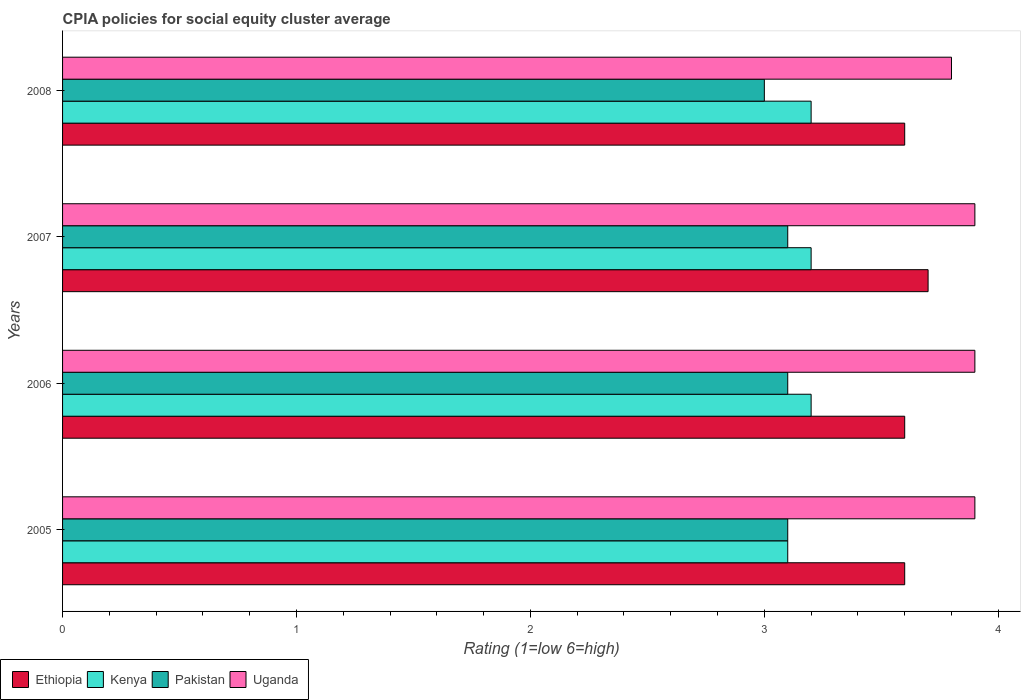Are the number of bars per tick equal to the number of legend labels?
Make the answer very short. Yes. Are the number of bars on each tick of the Y-axis equal?
Your response must be concise. Yes. In how many cases, is the number of bars for a given year not equal to the number of legend labels?
Keep it short and to the point. 0. Across all years, what is the maximum CPIA rating in Pakistan?
Give a very brief answer. 3.1. In which year was the CPIA rating in Pakistan minimum?
Offer a terse response. 2008. What is the difference between the CPIA rating in Kenya in 2006 and that in 2007?
Offer a terse response. 0. What is the difference between the CPIA rating in Uganda in 2006 and the CPIA rating in Ethiopia in 2007?
Keep it short and to the point. 0.2. What is the average CPIA rating in Ethiopia per year?
Keep it short and to the point. 3.62. In the year 2006, what is the difference between the CPIA rating in Ethiopia and CPIA rating in Uganda?
Give a very brief answer. -0.3. What is the ratio of the CPIA rating in Pakistan in 2005 to that in 2008?
Keep it short and to the point. 1.03. Is the difference between the CPIA rating in Ethiopia in 2007 and 2008 greater than the difference between the CPIA rating in Uganda in 2007 and 2008?
Keep it short and to the point. No. What is the difference between the highest and the lowest CPIA rating in Ethiopia?
Keep it short and to the point. 0.1. Is it the case that in every year, the sum of the CPIA rating in Kenya and CPIA rating in Uganda is greater than the sum of CPIA rating in Pakistan and CPIA rating in Ethiopia?
Provide a succinct answer. No. What does the 3rd bar from the top in 2006 represents?
Make the answer very short. Kenya. What does the 3rd bar from the bottom in 2007 represents?
Ensure brevity in your answer.  Pakistan. Is it the case that in every year, the sum of the CPIA rating in Pakistan and CPIA rating in Uganda is greater than the CPIA rating in Kenya?
Offer a terse response. Yes. How many bars are there?
Your answer should be compact. 16. Does the graph contain any zero values?
Keep it short and to the point. No. What is the title of the graph?
Your answer should be compact. CPIA policies for social equity cluster average. Does "Korea (Democratic)" appear as one of the legend labels in the graph?
Your answer should be very brief. No. What is the label or title of the X-axis?
Ensure brevity in your answer.  Rating (1=low 6=high). What is the label or title of the Y-axis?
Give a very brief answer. Years. What is the Rating (1=low 6=high) of Ethiopia in 2005?
Give a very brief answer. 3.6. What is the Rating (1=low 6=high) of Uganda in 2005?
Keep it short and to the point. 3.9. What is the Rating (1=low 6=high) in Ethiopia in 2006?
Provide a short and direct response. 3.6. What is the Rating (1=low 6=high) of Pakistan in 2006?
Your response must be concise. 3.1. What is the Rating (1=low 6=high) in Uganda in 2006?
Offer a very short reply. 3.9. What is the Rating (1=low 6=high) of Ethiopia in 2007?
Your answer should be compact. 3.7. What is the Rating (1=low 6=high) of Uganda in 2008?
Give a very brief answer. 3.8. Across all years, what is the maximum Rating (1=low 6=high) of Kenya?
Make the answer very short. 3.2. Across all years, what is the maximum Rating (1=low 6=high) in Uganda?
Keep it short and to the point. 3.9. Across all years, what is the minimum Rating (1=low 6=high) of Ethiopia?
Provide a short and direct response. 3.6. Across all years, what is the minimum Rating (1=low 6=high) of Kenya?
Keep it short and to the point. 3.1. Across all years, what is the minimum Rating (1=low 6=high) in Pakistan?
Keep it short and to the point. 3. What is the total Rating (1=low 6=high) of Ethiopia in the graph?
Offer a terse response. 14.5. What is the total Rating (1=low 6=high) of Pakistan in the graph?
Offer a very short reply. 12.3. What is the difference between the Rating (1=low 6=high) in Pakistan in 2005 and that in 2006?
Your response must be concise. 0. What is the difference between the Rating (1=low 6=high) in Ethiopia in 2005 and that in 2007?
Offer a very short reply. -0.1. What is the difference between the Rating (1=low 6=high) in Kenya in 2005 and that in 2007?
Provide a short and direct response. -0.1. What is the difference between the Rating (1=low 6=high) of Pakistan in 2005 and that in 2008?
Offer a very short reply. 0.1. What is the difference between the Rating (1=low 6=high) in Ethiopia in 2006 and that in 2007?
Make the answer very short. -0.1. What is the difference between the Rating (1=low 6=high) in Pakistan in 2006 and that in 2007?
Give a very brief answer. 0. What is the difference between the Rating (1=low 6=high) of Uganda in 2006 and that in 2007?
Ensure brevity in your answer.  0. What is the difference between the Rating (1=low 6=high) of Ethiopia in 2006 and that in 2008?
Make the answer very short. 0. What is the difference between the Rating (1=low 6=high) in Pakistan in 2006 and that in 2008?
Keep it short and to the point. 0.1. What is the difference between the Rating (1=low 6=high) in Ethiopia in 2007 and that in 2008?
Your answer should be very brief. 0.1. What is the difference between the Rating (1=low 6=high) in Kenya in 2007 and that in 2008?
Make the answer very short. 0. What is the difference between the Rating (1=low 6=high) in Uganda in 2007 and that in 2008?
Your response must be concise. 0.1. What is the difference between the Rating (1=low 6=high) in Ethiopia in 2005 and the Rating (1=low 6=high) in Pakistan in 2006?
Your answer should be compact. 0.5. What is the difference between the Rating (1=low 6=high) of Kenya in 2005 and the Rating (1=low 6=high) of Uganda in 2006?
Offer a terse response. -0.8. What is the difference between the Rating (1=low 6=high) in Pakistan in 2005 and the Rating (1=low 6=high) in Uganda in 2006?
Provide a succinct answer. -0.8. What is the difference between the Rating (1=low 6=high) in Ethiopia in 2005 and the Rating (1=low 6=high) in Pakistan in 2007?
Offer a terse response. 0.5. What is the difference between the Rating (1=low 6=high) in Ethiopia in 2005 and the Rating (1=low 6=high) in Uganda in 2007?
Offer a very short reply. -0.3. What is the difference between the Rating (1=low 6=high) in Pakistan in 2005 and the Rating (1=low 6=high) in Uganda in 2007?
Offer a terse response. -0.8. What is the difference between the Rating (1=low 6=high) in Ethiopia in 2005 and the Rating (1=low 6=high) in Pakistan in 2008?
Your response must be concise. 0.6. What is the difference between the Rating (1=low 6=high) in Ethiopia in 2005 and the Rating (1=low 6=high) in Uganda in 2008?
Provide a succinct answer. -0.2. What is the difference between the Rating (1=low 6=high) of Ethiopia in 2006 and the Rating (1=low 6=high) of Kenya in 2007?
Your answer should be compact. 0.4. What is the difference between the Rating (1=low 6=high) in Ethiopia in 2006 and the Rating (1=low 6=high) in Uganda in 2007?
Your answer should be compact. -0.3. What is the difference between the Rating (1=low 6=high) in Kenya in 2006 and the Rating (1=low 6=high) in Pakistan in 2007?
Keep it short and to the point. 0.1. What is the difference between the Rating (1=low 6=high) of Ethiopia in 2006 and the Rating (1=low 6=high) of Kenya in 2008?
Your answer should be very brief. 0.4. What is the difference between the Rating (1=low 6=high) of Ethiopia in 2006 and the Rating (1=low 6=high) of Pakistan in 2008?
Make the answer very short. 0.6. What is the difference between the Rating (1=low 6=high) of Ethiopia in 2006 and the Rating (1=low 6=high) of Uganda in 2008?
Give a very brief answer. -0.2. What is the difference between the Rating (1=low 6=high) in Pakistan in 2006 and the Rating (1=low 6=high) in Uganda in 2008?
Ensure brevity in your answer.  -0.7. What is the difference between the Rating (1=low 6=high) of Ethiopia in 2007 and the Rating (1=low 6=high) of Uganda in 2008?
Your answer should be compact. -0.1. What is the difference between the Rating (1=low 6=high) of Pakistan in 2007 and the Rating (1=low 6=high) of Uganda in 2008?
Provide a succinct answer. -0.7. What is the average Rating (1=low 6=high) of Ethiopia per year?
Offer a very short reply. 3.62. What is the average Rating (1=low 6=high) of Kenya per year?
Your response must be concise. 3.17. What is the average Rating (1=low 6=high) of Pakistan per year?
Make the answer very short. 3.08. What is the average Rating (1=low 6=high) in Uganda per year?
Keep it short and to the point. 3.88. In the year 2005, what is the difference between the Rating (1=low 6=high) in Kenya and Rating (1=low 6=high) in Pakistan?
Provide a short and direct response. 0. In the year 2005, what is the difference between the Rating (1=low 6=high) in Kenya and Rating (1=low 6=high) in Uganda?
Your response must be concise. -0.8. In the year 2005, what is the difference between the Rating (1=low 6=high) of Pakistan and Rating (1=low 6=high) of Uganda?
Ensure brevity in your answer.  -0.8. In the year 2006, what is the difference between the Rating (1=low 6=high) in Ethiopia and Rating (1=low 6=high) in Kenya?
Provide a short and direct response. 0.4. In the year 2006, what is the difference between the Rating (1=low 6=high) of Kenya and Rating (1=low 6=high) of Pakistan?
Your answer should be compact. 0.1. In the year 2006, what is the difference between the Rating (1=low 6=high) in Kenya and Rating (1=low 6=high) in Uganda?
Make the answer very short. -0.7. In the year 2007, what is the difference between the Rating (1=low 6=high) in Ethiopia and Rating (1=low 6=high) in Uganda?
Your answer should be compact. -0.2. In the year 2007, what is the difference between the Rating (1=low 6=high) of Pakistan and Rating (1=low 6=high) of Uganda?
Your response must be concise. -0.8. In the year 2008, what is the difference between the Rating (1=low 6=high) of Ethiopia and Rating (1=low 6=high) of Uganda?
Your answer should be compact. -0.2. In the year 2008, what is the difference between the Rating (1=low 6=high) in Kenya and Rating (1=low 6=high) in Pakistan?
Make the answer very short. 0.2. In the year 2008, what is the difference between the Rating (1=low 6=high) of Kenya and Rating (1=low 6=high) of Uganda?
Your answer should be compact. -0.6. In the year 2008, what is the difference between the Rating (1=low 6=high) of Pakistan and Rating (1=low 6=high) of Uganda?
Offer a terse response. -0.8. What is the ratio of the Rating (1=low 6=high) of Kenya in 2005 to that in 2006?
Offer a terse response. 0.97. What is the ratio of the Rating (1=low 6=high) in Pakistan in 2005 to that in 2006?
Provide a short and direct response. 1. What is the ratio of the Rating (1=low 6=high) in Uganda in 2005 to that in 2006?
Provide a succinct answer. 1. What is the ratio of the Rating (1=low 6=high) of Ethiopia in 2005 to that in 2007?
Make the answer very short. 0.97. What is the ratio of the Rating (1=low 6=high) in Kenya in 2005 to that in 2007?
Keep it short and to the point. 0.97. What is the ratio of the Rating (1=low 6=high) of Uganda in 2005 to that in 2007?
Give a very brief answer. 1. What is the ratio of the Rating (1=low 6=high) in Kenya in 2005 to that in 2008?
Your answer should be compact. 0.97. What is the ratio of the Rating (1=low 6=high) in Uganda in 2005 to that in 2008?
Offer a very short reply. 1.03. What is the ratio of the Rating (1=low 6=high) of Ethiopia in 2006 to that in 2007?
Make the answer very short. 0.97. What is the ratio of the Rating (1=low 6=high) of Pakistan in 2006 to that in 2007?
Offer a very short reply. 1. What is the ratio of the Rating (1=low 6=high) in Uganda in 2006 to that in 2007?
Ensure brevity in your answer.  1. What is the ratio of the Rating (1=low 6=high) in Kenya in 2006 to that in 2008?
Offer a very short reply. 1. What is the ratio of the Rating (1=low 6=high) of Pakistan in 2006 to that in 2008?
Your answer should be compact. 1.03. What is the ratio of the Rating (1=low 6=high) of Uganda in 2006 to that in 2008?
Offer a terse response. 1.03. What is the ratio of the Rating (1=low 6=high) in Ethiopia in 2007 to that in 2008?
Your response must be concise. 1.03. What is the ratio of the Rating (1=low 6=high) of Pakistan in 2007 to that in 2008?
Provide a succinct answer. 1.03. What is the ratio of the Rating (1=low 6=high) of Uganda in 2007 to that in 2008?
Offer a terse response. 1.03. What is the difference between the highest and the second highest Rating (1=low 6=high) in Ethiopia?
Provide a short and direct response. 0.1. What is the difference between the highest and the second highest Rating (1=low 6=high) of Kenya?
Give a very brief answer. 0. What is the difference between the highest and the second highest Rating (1=low 6=high) in Uganda?
Your answer should be compact. 0. What is the difference between the highest and the lowest Rating (1=low 6=high) in Pakistan?
Your answer should be compact. 0.1. What is the difference between the highest and the lowest Rating (1=low 6=high) of Uganda?
Your answer should be very brief. 0.1. 